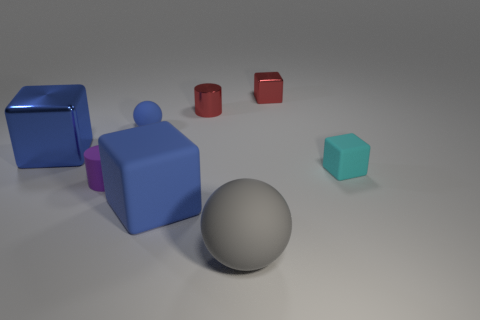How big is the ball that is to the right of the blue matte object in front of the matte cube behind the big rubber cube?
Give a very brief answer. Large. What is the size of the cylinder that is made of the same material as the red block?
Your answer should be very brief. Small. The thing that is both behind the cyan cube and on the left side of the blue rubber ball is what color?
Provide a short and direct response. Blue. Is the shape of the large object behind the rubber cylinder the same as the red metal thing to the right of the large matte sphere?
Offer a very short reply. Yes. There is a tiny cube that is right of the red block; what material is it?
Make the answer very short. Rubber. What is the size of the metallic thing that is the same color as the tiny ball?
Keep it short and to the point. Large. How many objects are either matte things behind the large shiny cube or small brown matte cylinders?
Give a very brief answer. 1. Are there an equal number of small cyan rubber cubes on the left side of the cyan thing and big brown shiny cylinders?
Your answer should be compact. Yes. Is the blue ball the same size as the blue metal cube?
Give a very brief answer. No. There is a rubber sphere that is the same size as the purple rubber object; what is its color?
Your answer should be compact. Blue. 